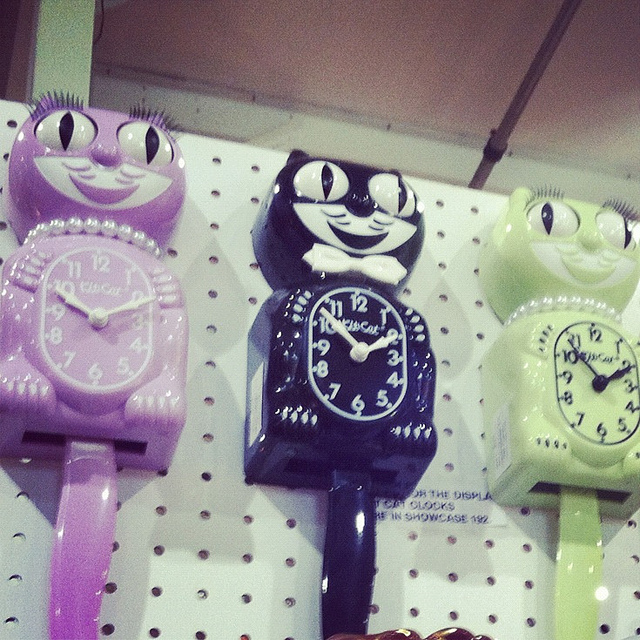Identify and read out the text in this image. DISPLA 4 12 8 10 1 2 3 4 5 6 7 10 SHOWCASE 9 7 6 5 3 8 12 